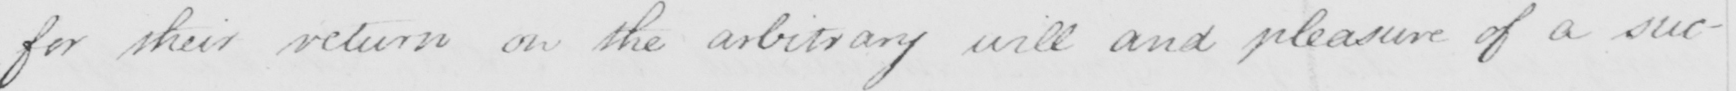Can you read and transcribe this handwriting? for their return on the arbitrary will and pleasure of a suc- 